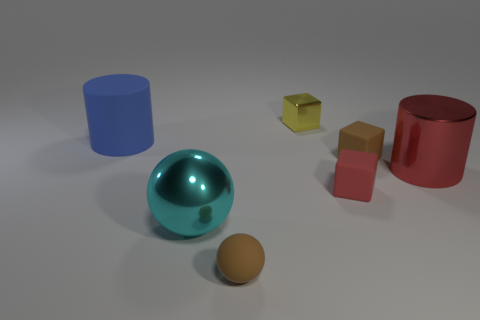Add 2 brown matte blocks. How many objects exist? 9 Subtract all cubes. How many objects are left? 4 Subtract 1 brown balls. How many objects are left? 6 Subtract all tiny rubber things. Subtract all small metallic cylinders. How many objects are left? 4 Add 4 big shiny objects. How many big shiny objects are left? 6 Add 2 big purple rubber balls. How many big purple rubber balls exist? 2 